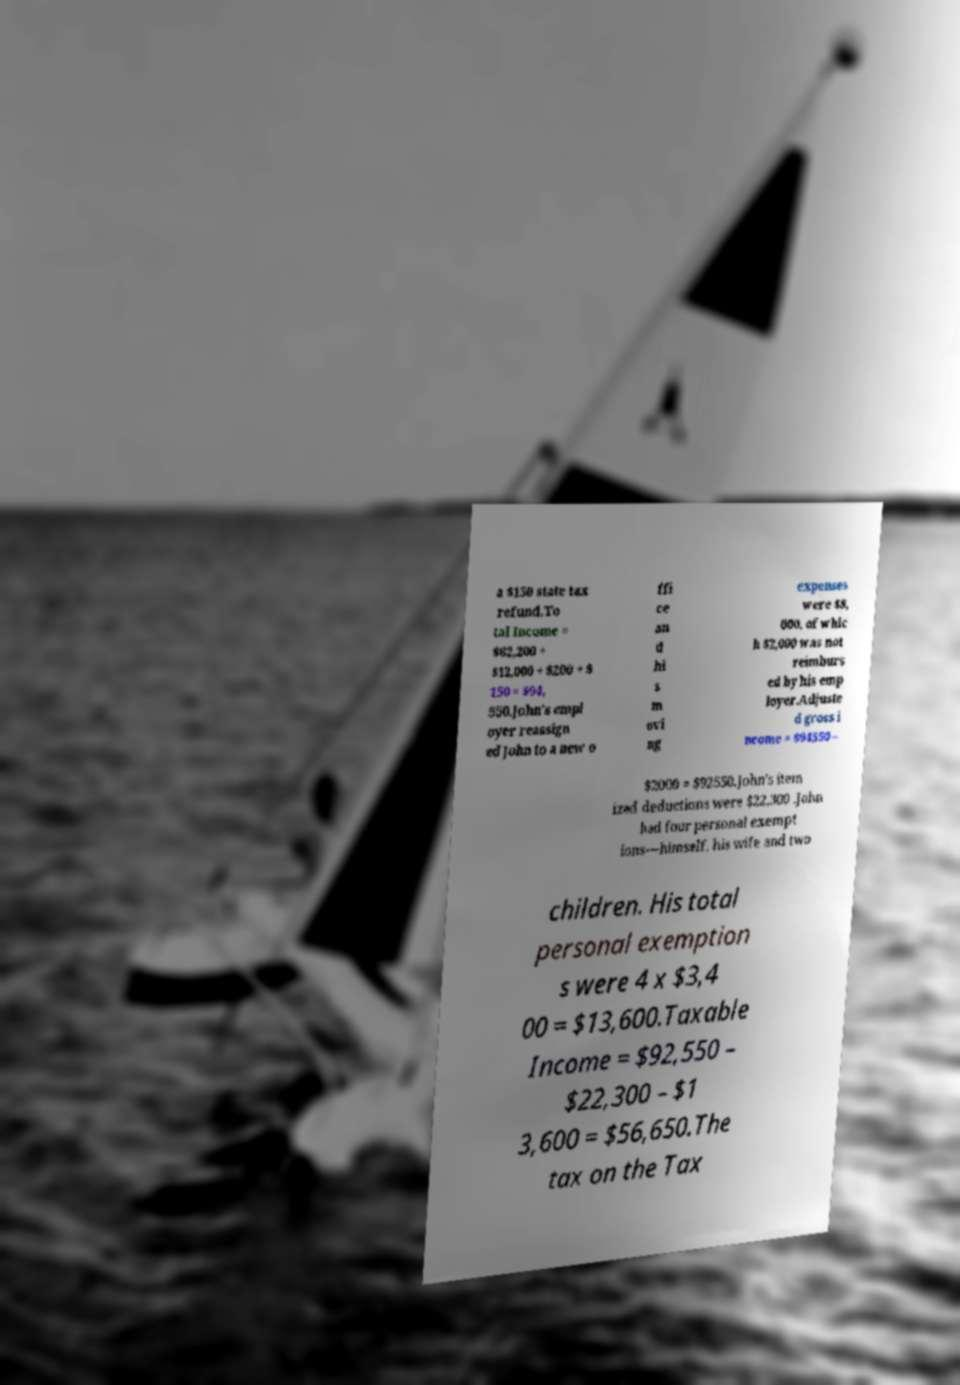There's text embedded in this image that I need extracted. Can you transcribe it verbatim? a $150 state tax refund.To tal Income = $82,200 + $12,000 + $200 + $ 150 = $94, 550.John's empl oyer reassign ed John to a new o ffi ce an d hi s m ovi ng expenses were $8, 000, of whic h $2,000 was not reimburs ed by his emp loyer.Adjuste d gross i ncome = $94550 – $2000 = $92550.John's item ized deductions were $22,300 .John had four personal exempt ions—himself, his wife and two children. His total personal exemption s were 4 x $3,4 00 = $13,600.Taxable Income = $92,550 – $22,300 – $1 3,600 = $56,650.The tax on the Tax 